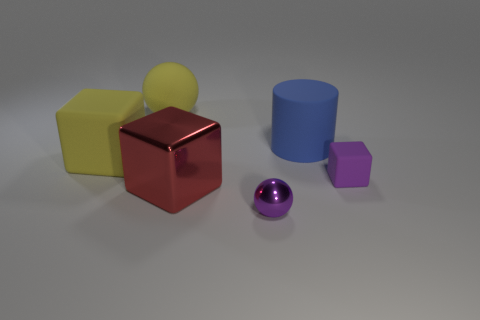Add 3 metal blocks. How many objects exist? 9 Subtract all balls. How many objects are left? 4 Add 2 yellow matte blocks. How many yellow matte blocks are left? 3 Add 3 big yellow rubber things. How many big yellow rubber things exist? 5 Subtract 0 purple cylinders. How many objects are left? 6 Subtract all metal spheres. Subtract all big brown metal things. How many objects are left? 5 